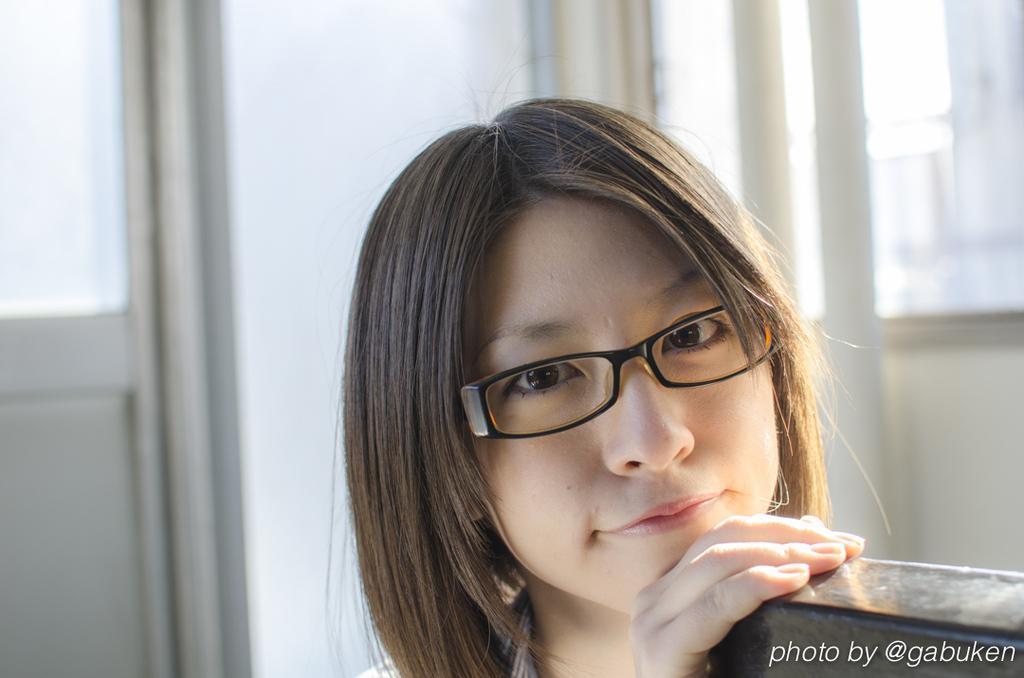How would you summarize this image in a sentence or two? In this image there is a girl who is wearing the black color specs, has kept her hands on the wooden desk. In the background there is a door on the left side and a windows on the right side. 